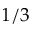Convert formula to latex. <formula><loc_0><loc_0><loc_500><loc_500>1 / 3</formula> 